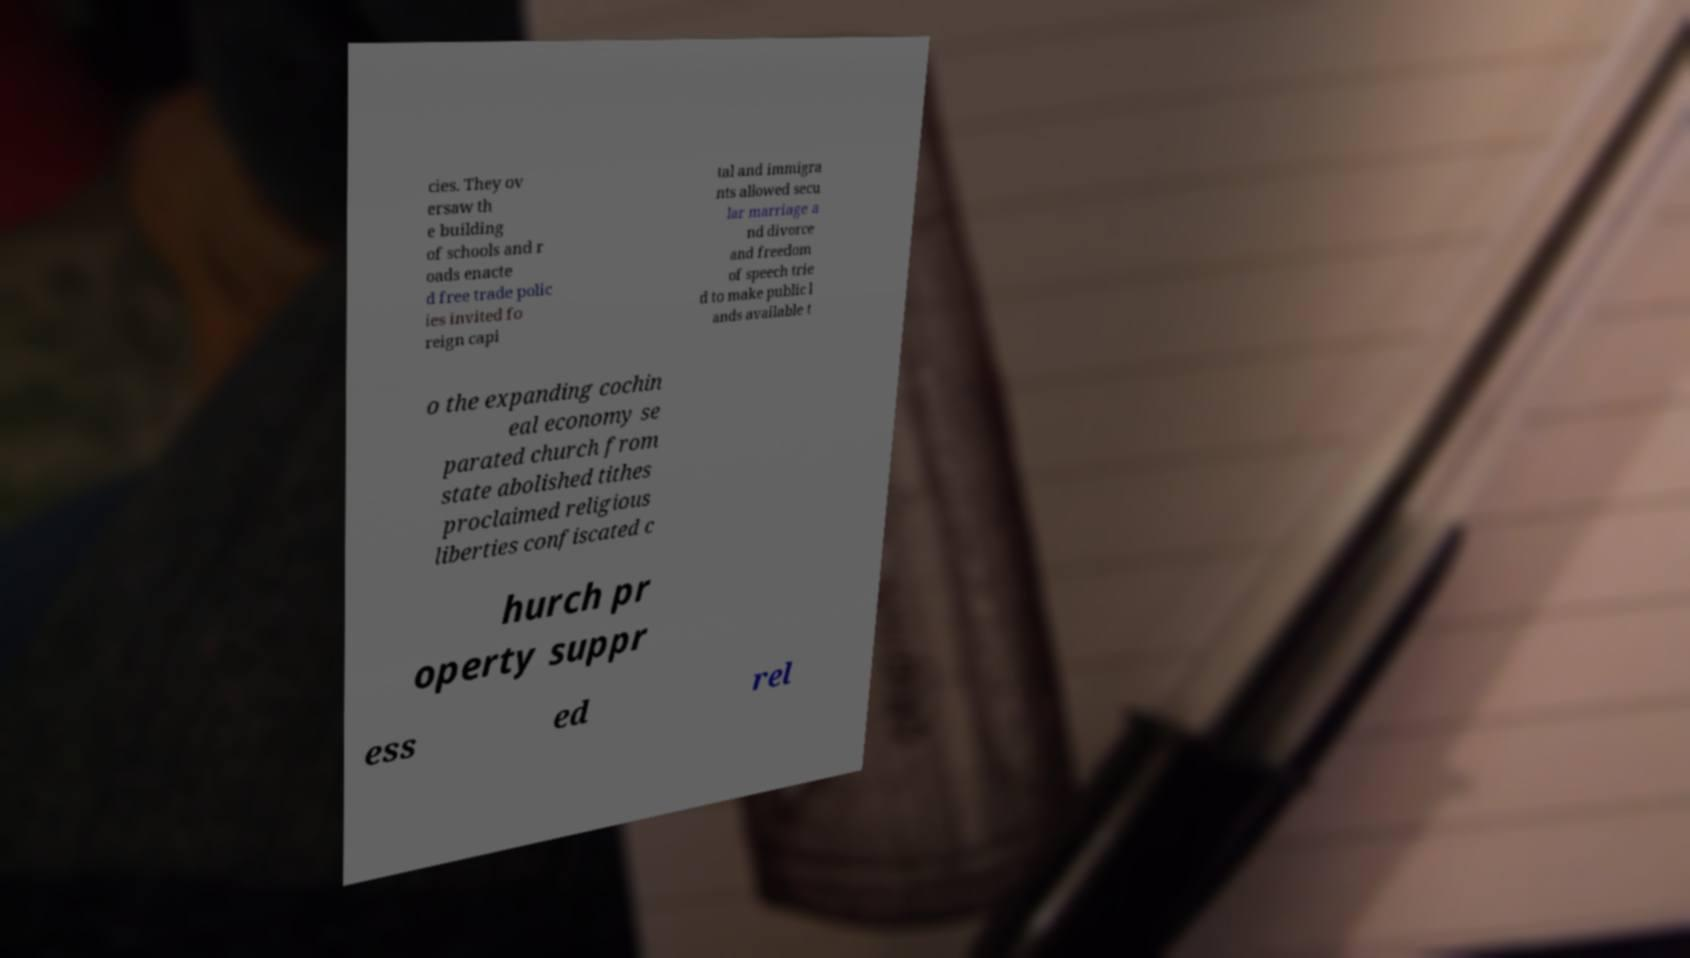Can you read and provide the text displayed in the image?This photo seems to have some interesting text. Can you extract and type it out for me? cies. They ov ersaw th e building of schools and r oads enacte d free trade polic ies invited fo reign capi tal and immigra nts allowed secu lar marriage a nd divorce and freedom of speech trie d to make public l ands available t o the expanding cochin eal economy se parated church from state abolished tithes proclaimed religious liberties confiscated c hurch pr operty suppr ess ed rel 